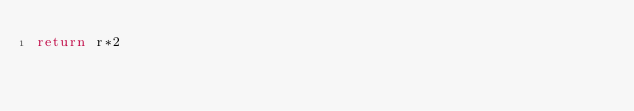<code> <loc_0><loc_0><loc_500><loc_500><_JavaScript_>return r*2</code> 